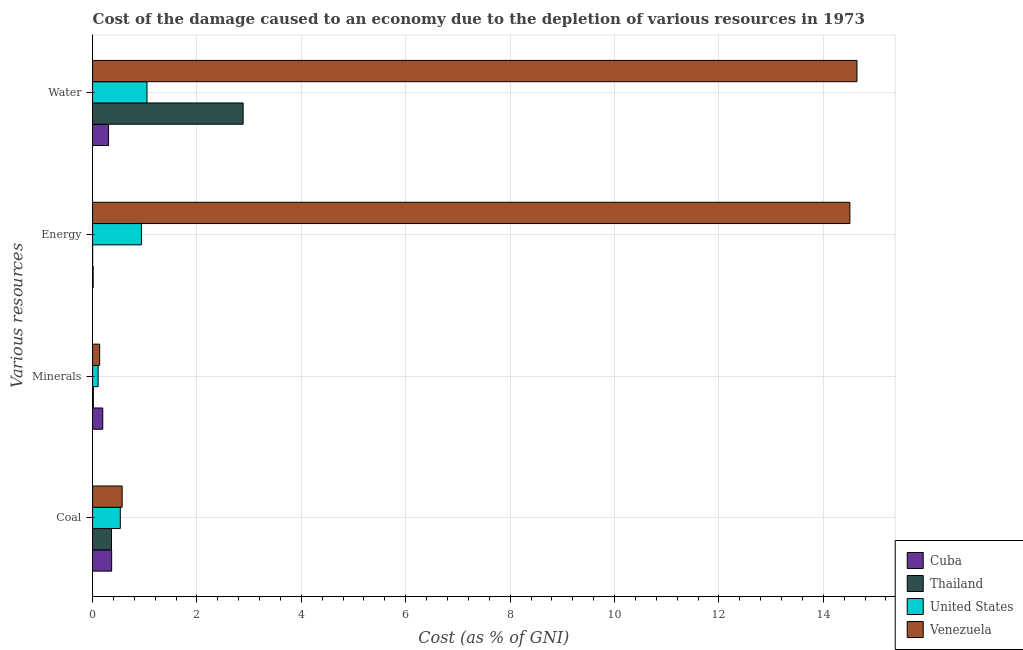Are the number of bars per tick equal to the number of legend labels?
Your response must be concise. Yes. How many bars are there on the 4th tick from the bottom?
Keep it short and to the point. 4. What is the label of the 3rd group of bars from the top?
Your response must be concise. Minerals. What is the cost of damage due to depletion of minerals in Cuba?
Offer a very short reply. 0.2. Across all countries, what is the maximum cost of damage due to depletion of water?
Ensure brevity in your answer.  14.65. Across all countries, what is the minimum cost of damage due to depletion of coal?
Provide a short and direct response. 0.36. In which country was the cost of damage due to depletion of energy maximum?
Make the answer very short. Venezuela. In which country was the cost of damage due to depletion of minerals minimum?
Make the answer very short. Thailand. What is the total cost of damage due to depletion of minerals in the graph?
Provide a short and direct response. 0.45. What is the difference between the cost of damage due to depletion of energy in Cuba and that in Thailand?
Ensure brevity in your answer.  0.01. What is the difference between the cost of damage due to depletion of coal in United States and the cost of damage due to depletion of water in Thailand?
Your response must be concise. -2.35. What is the average cost of damage due to depletion of coal per country?
Ensure brevity in your answer.  0.46. What is the difference between the cost of damage due to depletion of minerals and cost of damage due to depletion of coal in Cuba?
Your answer should be very brief. -0.17. In how many countries, is the cost of damage due to depletion of water greater than 12 %?
Keep it short and to the point. 1. What is the ratio of the cost of damage due to depletion of water in Thailand to that in United States?
Your response must be concise. 2.77. Is the cost of damage due to depletion of water in Cuba less than that in United States?
Your response must be concise. Yes. Is the difference between the cost of damage due to depletion of minerals in Cuba and Venezuela greater than the difference between the cost of damage due to depletion of energy in Cuba and Venezuela?
Your answer should be compact. Yes. What is the difference between the highest and the second highest cost of damage due to depletion of water?
Offer a very short reply. 11.76. What is the difference between the highest and the lowest cost of damage due to depletion of energy?
Provide a short and direct response. 14.51. In how many countries, is the cost of damage due to depletion of water greater than the average cost of damage due to depletion of water taken over all countries?
Your answer should be very brief. 1. Is it the case that in every country, the sum of the cost of damage due to depletion of minerals and cost of damage due to depletion of coal is greater than the sum of cost of damage due to depletion of water and cost of damage due to depletion of energy?
Your answer should be compact. No. What does the 1st bar from the top in Coal represents?
Your answer should be very brief. Venezuela. What does the 1st bar from the bottom in Minerals represents?
Your response must be concise. Cuba. What is the difference between two consecutive major ticks on the X-axis?
Offer a very short reply. 2. Are the values on the major ticks of X-axis written in scientific E-notation?
Provide a short and direct response. No. Does the graph contain grids?
Ensure brevity in your answer.  Yes. Where does the legend appear in the graph?
Provide a short and direct response. Bottom right. How many legend labels are there?
Make the answer very short. 4. What is the title of the graph?
Your answer should be compact. Cost of the damage caused to an economy due to the depletion of various resources in 1973 . What is the label or title of the X-axis?
Offer a very short reply. Cost (as % of GNI). What is the label or title of the Y-axis?
Offer a very short reply. Various resources. What is the Cost (as % of GNI) in Cuba in Coal?
Your answer should be very brief. 0.37. What is the Cost (as % of GNI) of Thailand in Coal?
Your answer should be compact. 0.36. What is the Cost (as % of GNI) of United States in Coal?
Ensure brevity in your answer.  0.53. What is the Cost (as % of GNI) of Venezuela in Coal?
Your response must be concise. 0.57. What is the Cost (as % of GNI) of Cuba in Minerals?
Your answer should be very brief. 0.2. What is the Cost (as % of GNI) in Thailand in Minerals?
Give a very brief answer. 0.01. What is the Cost (as % of GNI) in United States in Minerals?
Provide a succinct answer. 0.11. What is the Cost (as % of GNI) of Venezuela in Minerals?
Your answer should be very brief. 0.14. What is the Cost (as % of GNI) of Cuba in Energy?
Your answer should be very brief. 0.01. What is the Cost (as % of GNI) of Thailand in Energy?
Provide a short and direct response. 0. What is the Cost (as % of GNI) of United States in Energy?
Ensure brevity in your answer.  0.94. What is the Cost (as % of GNI) in Venezuela in Energy?
Ensure brevity in your answer.  14.51. What is the Cost (as % of GNI) in Cuba in Water?
Keep it short and to the point. 0.31. What is the Cost (as % of GNI) of Thailand in Water?
Ensure brevity in your answer.  2.88. What is the Cost (as % of GNI) of United States in Water?
Ensure brevity in your answer.  1.04. What is the Cost (as % of GNI) of Venezuela in Water?
Your answer should be very brief. 14.65. Across all Various resources, what is the maximum Cost (as % of GNI) in Cuba?
Offer a terse response. 0.37. Across all Various resources, what is the maximum Cost (as % of GNI) of Thailand?
Offer a terse response. 2.88. Across all Various resources, what is the maximum Cost (as % of GNI) of United States?
Give a very brief answer. 1.04. Across all Various resources, what is the maximum Cost (as % of GNI) in Venezuela?
Make the answer very short. 14.65. Across all Various resources, what is the minimum Cost (as % of GNI) of Cuba?
Ensure brevity in your answer.  0.01. Across all Various resources, what is the minimum Cost (as % of GNI) in Thailand?
Ensure brevity in your answer.  0. Across all Various resources, what is the minimum Cost (as % of GNI) of United States?
Your answer should be compact. 0.11. Across all Various resources, what is the minimum Cost (as % of GNI) of Venezuela?
Keep it short and to the point. 0.14. What is the total Cost (as % of GNI) of Cuba in the graph?
Give a very brief answer. 0.88. What is the total Cost (as % of GNI) in Thailand in the graph?
Make the answer very short. 3.26. What is the total Cost (as % of GNI) in United States in the graph?
Make the answer very short. 2.62. What is the total Cost (as % of GNI) in Venezuela in the graph?
Make the answer very short. 29.86. What is the difference between the Cost (as % of GNI) of Cuba in Coal and that in Minerals?
Your answer should be very brief. 0.17. What is the difference between the Cost (as % of GNI) in Thailand in Coal and that in Minerals?
Keep it short and to the point. 0.35. What is the difference between the Cost (as % of GNI) in United States in Coal and that in Minerals?
Keep it short and to the point. 0.42. What is the difference between the Cost (as % of GNI) of Venezuela in Coal and that in Minerals?
Give a very brief answer. 0.43. What is the difference between the Cost (as % of GNI) in Cuba in Coal and that in Energy?
Your response must be concise. 0.35. What is the difference between the Cost (as % of GNI) in Thailand in Coal and that in Energy?
Make the answer very short. 0.36. What is the difference between the Cost (as % of GNI) of United States in Coal and that in Energy?
Give a very brief answer. -0.41. What is the difference between the Cost (as % of GNI) in Venezuela in Coal and that in Energy?
Keep it short and to the point. -13.94. What is the difference between the Cost (as % of GNI) in Cuba in Coal and that in Water?
Provide a short and direct response. 0.06. What is the difference between the Cost (as % of GNI) in Thailand in Coal and that in Water?
Offer a terse response. -2.52. What is the difference between the Cost (as % of GNI) in United States in Coal and that in Water?
Keep it short and to the point. -0.51. What is the difference between the Cost (as % of GNI) of Venezuela in Coal and that in Water?
Provide a succinct answer. -14.08. What is the difference between the Cost (as % of GNI) of Cuba in Minerals and that in Energy?
Ensure brevity in your answer.  0.18. What is the difference between the Cost (as % of GNI) in Thailand in Minerals and that in Energy?
Provide a succinct answer. 0.01. What is the difference between the Cost (as % of GNI) of United States in Minerals and that in Energy?
Ensure brevity in your answer.  -0.83. What is the difference between the Cost (as % of GNI) in Venezuela in Minerals and that in Energy?
Make the answer very short. -14.37. What is the difference between the Cost (as % of GNI) in Cuba in Minerals and that in Water?
Provide a succinct answer. -0.11. What is the difference between the Cost (as % of GNI) of Thailand in Minerals and that in Water?
Give a very brief answer. -2.87. What is the difference between the Cost (as % of GNI) of United States in Minerals and that in Water?
Ensure brevity in your answer.  -0.94. What is the difference between the Cost (as % of GNI) of Venezuela in Minerals and that in Water?
Your answer should be very brief. -14.51. What is the difference between the Cost (as % of GNI) of Cuba in Energy and that in Water?
Provide a short and direct response. -0.29. What is the difference between the Cost (as % of GNI) of Thailand in Energy and that in Water?
Ensure brevity in your answer.  -2.88. What is the difference between the Cost (as % of GNI) of United States in Energy and that in Water?
Your answer should be very brief. -0.11. What is the difference between the Cost (as % of GNI) of Venezuela in Energy and that in Water?
Make the answer very short. -0.14. What is the difference between the Cost (as % of GNI) in Cuba in Coal and the Cost (as % of GNI) in Thailand in Minerals?
Provide a succinct answer. 0.35. What is the difference between the Cost (as % of GNI) in Cuba in Coal and the Cost (as % of GNI) in United States in Minerals?
Ensure brevity in your answer.  0.26. What is the difference between the Cost (as % of GNI) of Cuba in Coal and the Cost (as % of GNI) of Venezuela in Minerals?
Your answer should be very brief. 0.23. What is the difference between the Cost (as % of GNI) of Thailand in Coal and the Cost (as % of GNI) of United States in Minerals?
Your answer should be compact. 0.26. What is the difference between the Cost (as % of GNI) of Thailand in Coal and the Cost (as % of GNI) of Venezuela in Minerals?
Your answer should be compact. 0.23. What is the difference between the Cost (as % of GNI) of United States in Coal and the Cost (as % of GNI) of Venezuela in Minerals?
Offer a very short reply. 0.4. What is the difference between the Cost (as % of GNI) in Cuba in Coal and the Cost (as % of GNI) in Thailand in Energy?
Your answer should be compact. 0.36. What is the difference between the Cost (as % of GNI) of Cuba in Coal and the Cost (as % of GNI) of United States in Energy?
Provide a short and direct response. -0.57. What is the difference between the Cost (as % of GNI) in Cuba in Coal and the Cost (as % of GNI) in Venezuela in Energy?
Your answer should be compact. -14.14. What is the difference between the Cost (as % of GNI) in Thailand in Coal and the Cost (as % of GNI) in United States in Energy?
Your answer should be very brief. -0.57. What is the difference between the Cost (as % of GNI) of Thailand in Coal and the Cost (as % of GNI) of Venezuela in Energy?
Offer a terse response. -14.15. What is the difference between the Cost (as % of GNI) in United States in Coal and the Cost (as % of GNI) in Venezuela in Energy?
Provide a short and direct response. -13.98. What is the difference between the Cost (as % of GNI) in Cuba in Coal and the Cost (as % of GNI) in Thailand in Water?
Give a very brief answer. -2.52. What is the difference between the Cost (as % of GNI) in Cuba in Coal and the Cost (as % of GNI) in United States in Water?
Give a very brief answer. -0.68. What is the difference between the Cost (as % of GNI) of Cuba in Coal and the Cost (as % of GNI) of Venezuela in Water?
Your answer should be very brief. -14.28. What is the difference between the Cost (as % of GNI) in Thailand in Coal and the Cost (as % of GNI) in United States in Water?
Your answer should be compact. -0.68. What is the difference between the Cost (as % of GNI) in Thailand in Coal and the Cost (as % of GNI) in Venezuela in Water?
Give a very brief answer. -14.28. What is the difference between the Cost (as % of GNI) of United States in Coal and the Cost (as % of GNI) of Venezuela in Water?
Make the answer very short. -14.11. What is the difference between the Cost (as % of GNI) of Cuba in Minerals and the Cost (as % of GNI) of Thailand in Energy?
Give a very brief answer. 0.19. What is the difference between the Cost (as % of GNI) of Cuba in Minerals and the Cost (as % of GNI) of United States in Energy?
Provide a succinct answer. -0.74. What is the difference between the Cost (as % of GNI) of Cuba in Minerals and the Cost (as % of GNI) of Venezuela in Energy?
Your answer should be compact. -14.31. What is the difference between the Cost (as % of GNI) in Thailand in Minerals and the Cost (as % of GNI) in United States in Energy?
Provide a short and direct response. -0.92. What is the difference between the Cost (as % of GNI) of Thailand in Minerals and the Cost (as % of GNI) of Venezuela in Energy?
Give a very brief answer. -14.49. What is the difference between the Cost (as % of GNI) of United States in Minerals and the Cost (as % of GNI) of Venezuela in Energy?
Give a very brief answer. -14.4. What is the difference between the Cost (as % of GNI) of Cuba in Minerals and the Cost (as % of GNI) of Thailand in Water?
Your answer should be very brief. -2.69. What is the difference between the Cost (as % of GNI) of Cuba in Minerals and the Cost (as % of GNI) of United States in Water?
Offer a very short reply. -0.85. What is the difference between the Cost (as % of GNI) of Cuba in Minerals and the Cost (as % of GNI) of Venezuela in Water?
Your answer should be compact. -14.45. What is the difference between the Cost (as % of GNI) in Thailand in Minerals and the Cost (as % of GNI) in United States in Water?
Offer a terse response. -1.03. What is the difference between the Cost (as % of GNI) of Thailand in Minerals and the Cost (as % of GNI) of Venezuela in Water?
Keep it short and to the point. -14.63. What is the difference between the Cost (as % of GNI) of United States in Minerals and the Cost (as % of GNI) of Venezuela in Water?
Ensure brevity in your answer.  -14.54. What is the difference between the Cost (as % of GNI) of Cuba in Energy and the Cost (as % of GNI) of Thailand in Water?
Offer a terse response. -2.87. What is the difference between the Cost (as % of GNI) in Cuba in Energy and the Cost (as % of GNI) in United States in Water?
Provide a succinct answer. -1.03. What is the difference between the Cost (as % of GNI) of Cuba in Energy and the Cost (as % of GNI) of Venezuela in Water?
Offer a very short reply. -14.63. What is the difference between the Cost (as % of GNI) of Thailand in Energy and the Cost (as % of GNI) of United States in Water?
Your answer should be compact. -1.04. What is the difference between the Cost (as % of GNI) in Thailand in Energy and the Cost (as % of GNI) in Venezuela in Water?
Ensure brevity in your answer.  -14.64. What is the difference between the Cost (as % of GNI) in United States in Energy and the Cost (as % of GNI) in Venezuela in Water?
Make the answer very short. -13.71. What is the average Cost (as % of GNI) in Cuba per Various resources?
Provide a succinct answer. 0.22. What is the average Cost (as % of GNI) in Thailand per Various resources?
Your answer should be compact. 0.82. What is the average Cost (as % of GNI) of United States per Various resources?
Your answer should be compact. 0.65. What is the average Cost (as % of GNI) in Venezuela per Various resources?
Give a very brief answer. 7.46. What is the difference between the Cost (as % of GNI) in Cuba and Cost (as % of GNI) in Thailand in Coal?
Give a very brief answer. 0. What is the difference between the Cost (as % of GNI) in Cuba and Cost (as % of GNI) in United States in Coal?
Your answer should be very brief. -0.17. What is the difference between the Cost (as % of GNI) in Cuba and Cost (as % of GNI) in Venezuela in Coal?
Keep it short and to the point. -0.2. What is the difference between the Cost (as % of GNI) in Thailand and Cost (as % of GNI) in United States in Coal?
Make the answer very short. -0.17. What is the difference between the Cost (as % of GNI) in Thailand and Cost (as % of GNI) in Venezuela in Coal?
Your response must be concise. -0.2. What is the difference between the Cost (as % of GNI) in United States and Cost (as % of GNI) in Venezuela in Coal?
Offer a very short reply. -0.04. What is the difference between the Cost (as % of GNI) in Cuba and Cost (as % of GNI) in Thailand in Minerals?
Provide a short and direct response. 0.18. What is the difference between the Cost (as % of GNI) of Cuba and Cost (as % of GNI) of United States in Minerals?
Your response must be concise. 0.09. What is the difference between the Cost (as % of GNI) of Cuba and Cost (as % of GNI) of Venezuela in Minerals?
Your response must be concise. 0.06. What is the difference between the Cost (as % of GNI) in Thailand and Cost (as % of GNI) in United States in Minerals?
Provide a short and direct response. -0.09. What is the difference between the Cost (as % of GNI) in Thailand and Cost (as % of GNI) in Venezuela in Minerals?
Provide a short and direct response. -0.12. What is the difference between the Cost (as % of GNI) in United States and Cost (as % of GNI) in Venezuela in Minerals?
Keep it short and to the point. -0.03. What is the difference between the Cost (as % of GNI) in Cuba and Cost (as % of GNI) in Thailand in Energy?
Ensure brevity in your answer.  0.01. What is the difference between the Cost (as % of GNI) in Cuba and Cost (as % of GNI) in United States in Energy?
Your answer should be compact. -0.93. What is the difference between the Cost (as % of GNI) of Cuba and Cost (as % of GNI) of Venezuela in Energy?
Your answer should be very brief. -14.5. What is the difference between the Cost (as % of GNI) in Thailand and Cost (as % of GNI) in United States in Energy?
Keep it short and to the point. -0.93. What is the difference between the Cost (as % of GNI) of Thailand and Cost (as % of GNI) of Venezuela in Energy?
Make the answer very short. -14.51. What is the difference between the Cost (as % of GNI) of United States and Cost (as % of GNI) of Venezuela in Energy?
Offer a very short reply. -13.57. What is the difference between the Cost (as % of GNI) of Cuba and Cost (as % of GNI) of Thailand in Water?
Offer a terse response. -2.58. What is the difference between the Cost (as % of GNI) of Cuba and Cost (as % of GNI) of United States in Water?
Keep it short and to the point. -0.74. What is the difference between the Cost (as % of GNI) of Cuba and Cost (as % of GNI) of Venezuela in Water?
Your response must be concise. -14.34. What is the difference between the Cost (as % of GNI) of Thailand and Cost (as % of GNI) of United States in Water?
Provide a short and direct response. 1.84. What is the difference between the Cost (as % of GNI) in Thailand and Cost (as % of GNI) in Venezuela in Water?
Your answer should be very brief. -11.76. What is the difference between the Cost (as % of GNI) in United States and Cost (as % of GNI) in Venezuela in Water?
Keep it short and to the point. -13.6. What is the ratio of the Cost (as % of GNI) in Cuba in Coal to that in Minerals?
Your answer should be compact. 1.87. What is the ratio of the Cost (as % of GNI) of Thailand in Coal to that in Minerals?
Offer a terse response. 24.36. What is the ratio of the Cost (as % of GNI) in United States in Coal to that in Minerals?
Your answer should be compact. 4.99. What is the ratio of the Cost (as % of GNI) of Venezuela in Coal to that in Minerals?
Offer a very short reply. 4.17. What is the ratio of the Cost (as % of GNI) in Cuba in Coal to that in Energy?
Keep it short and to the point. 32.39. What is the ratio of the Cost (as % of GNI) in Thailand in Coal to that in Energy?
Ensure brevity in your answer.  214.32. What is the ratio of the Cost (as % of GNI) in United States in Coal to that in Energy?
Provide a short and direct response. 0.57. What is the ratio of the Cost (as % of GNI) in Venezuela in Coal to that in Energy?
Offer a very short reply. 0.04. What is the ratio of the Cost (as % of GNI) in Cuba in Coal to that in Water?
Keep it short and to the point. 1.19. What is the ratio of the Cost (as % of GNI) in Thailand in Coal to that in Water?
Provide a succinct answer. 0.13. What is the ratio of the Cost (as % of GNI) in United States in Coal to that in Water?
Provide a short and direct response. 0.51. What is the ratio of the Cost (as % of GNI) of Venezuela in Coal to that in Water?
Your answer should be compact. 0.04. What is the ratio of the Cost (as % of GNI) of Cuba in Minerals to that in Energy?
Keep it short and to the point. 17.31. What is the ratio of the Cost (as % of GNI) of Thailand in Minerals to that in Energy?
Make the answer very short. 8.8. What is the ratio of the Cost (as % of GNI) of United States in Minerals to that in Energy?
Give a very brief answer. 0.11. What is the ratio of the Cost (as % of GNI) of Venezuela in Minerals to that in Energy?
Ensure brevity in your answer.  0.01. What is the ratio of the Cost (as % of GNI) of Cuba in Minerals to that in Water?
Keep it short and to the point. 0.64. What is the ratio of the Cost (as % of GNI) of Thailand in Minerals to that in Water?
Provide a short and direct response. 0.01. What is the ratio of the Cost (as % of GNI) of United States in Minerals to that in Water?
Offer a very short reply. 0.1. What is the ratio of the Cost (as % of GNI) of Venezuela in Minerals to that in Water?
Offer a terse response. 0.01. What is the ratio of the Cost (as % of GNI) of Cuba in Energy to that in Water?
Offer a terse response. 0.04. What is the ratio of the Cost (as % of GNI) of Thailand in Energy to that in Water?
Provide a short and direct response. 0. What is the ratio of the Cost (as % of GNI) in United States in Energy to that in Water?
Offer a terse response. 0.9. What is the difference between the highest and the second highest Cost (as % of GNI) in Cuba?
Your answer should be compact. 0.06. What is the difference between the highest and the second highest Cost (as % of GNI) of Thailand?
Offer a very short reply. 2.52. What is the difference between the highest and the second highest Cost (as % of GNI) in United States?
Offer a very short reply. 0.11. What is the difference between the highest and the second highest Cost (as % of GNI) in Venezuela?
Provide a short and direct response. 0.14. What is the difference between the highest and the lowest Cost (as % of GNI) in Cuba?
Give a very brief answer. 0.35. What is the difference between the highest and the lowest Cost (as % of GNI) of Thailand?
Offer a very short reply. 2.88. What is the difference between the highest and the lowest Cost (as % of GNI) of United States?
Offer a very short reply. 0.94. What is the difference between the highest and the lowest Cost (as % of GNI) in Venezuela?
Ensure brevity in your answer.  14.51. 